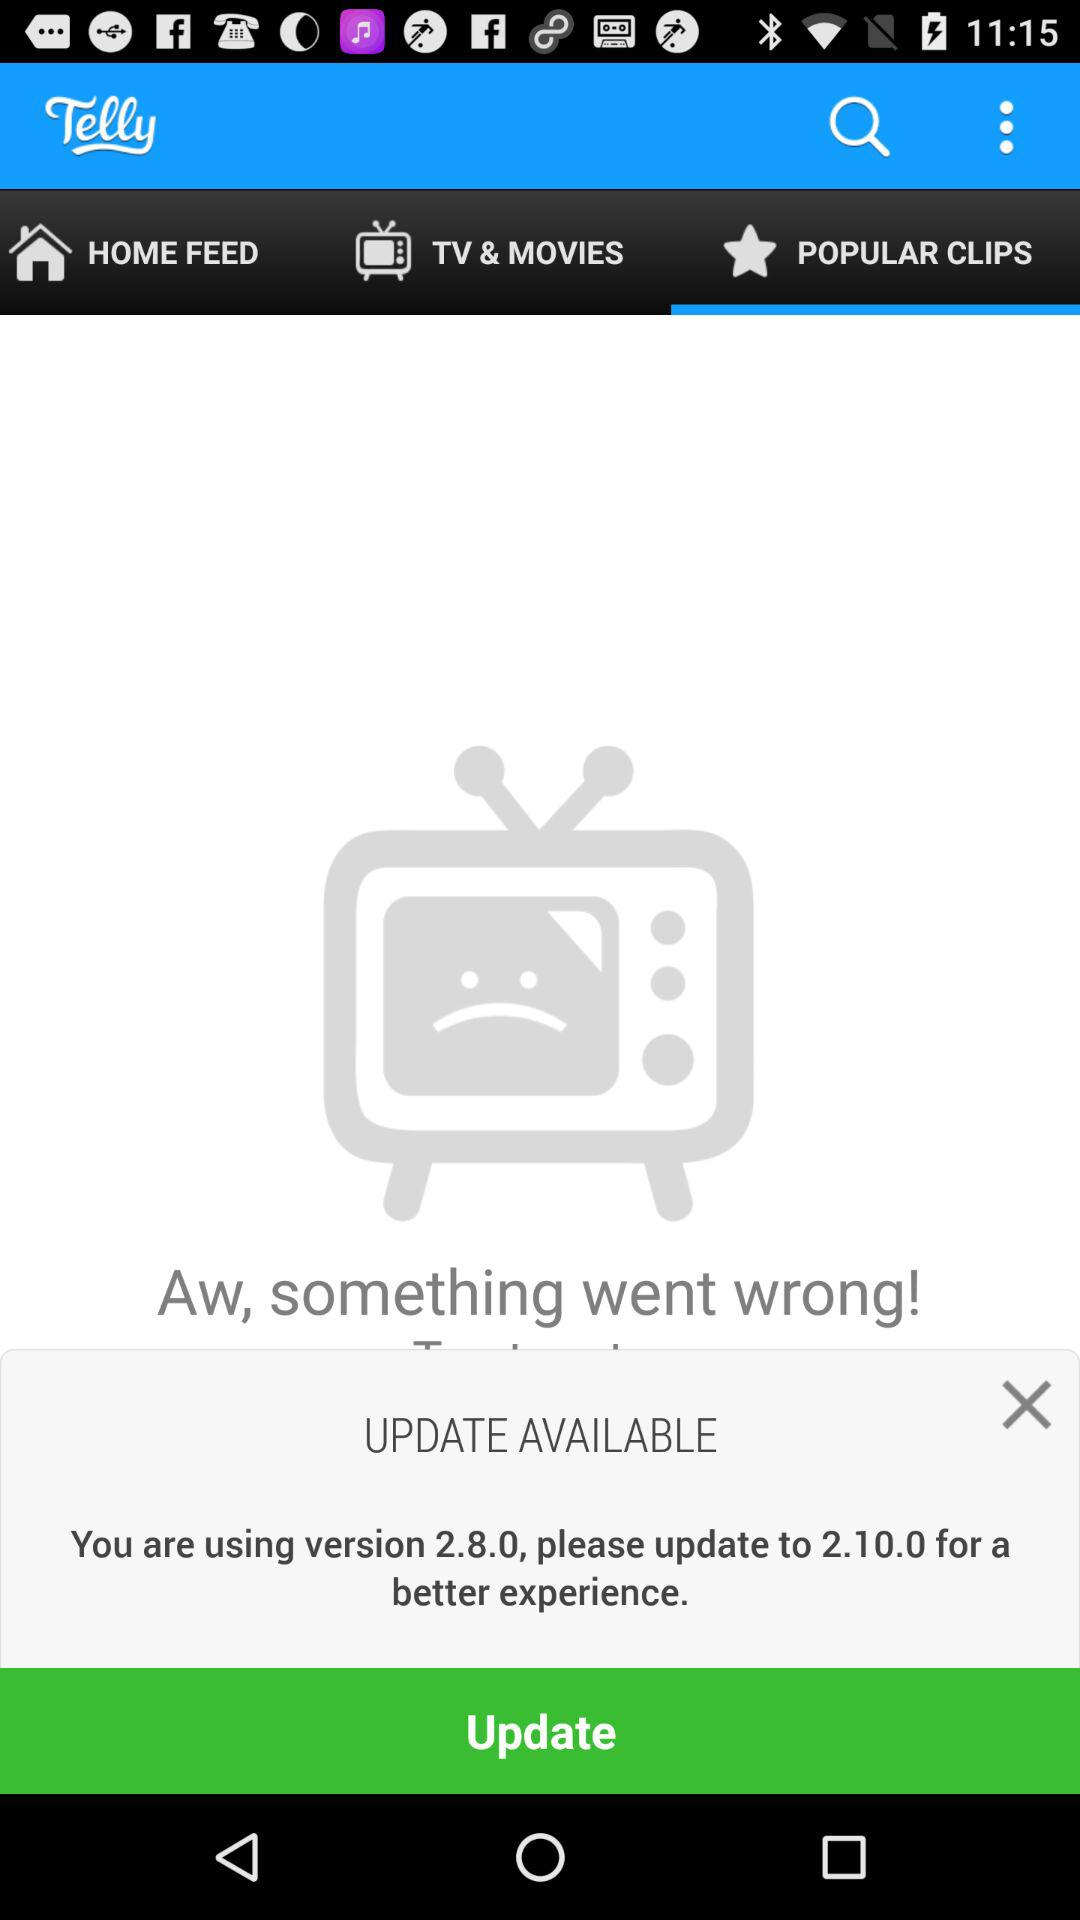How many versions of the app are available?
Answer the question using a single word or phrase. 2 